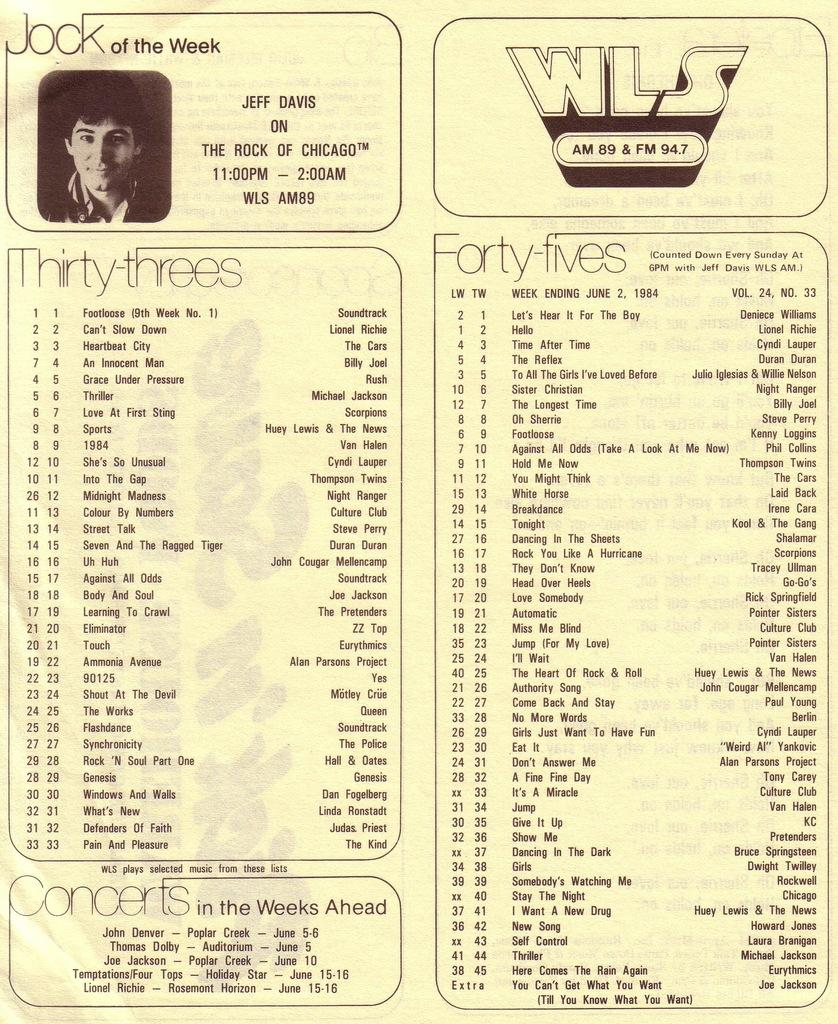What is present on the poster in the image? There is a poster in the image that contains text and a picture of a person. Can you describe the content of the poster? The poster contains text and a picture of a person. How many geese are flying in the picture of the person on the poster? There are no geese present in the image, and the picture of the person on the poster does not depict any geese. 